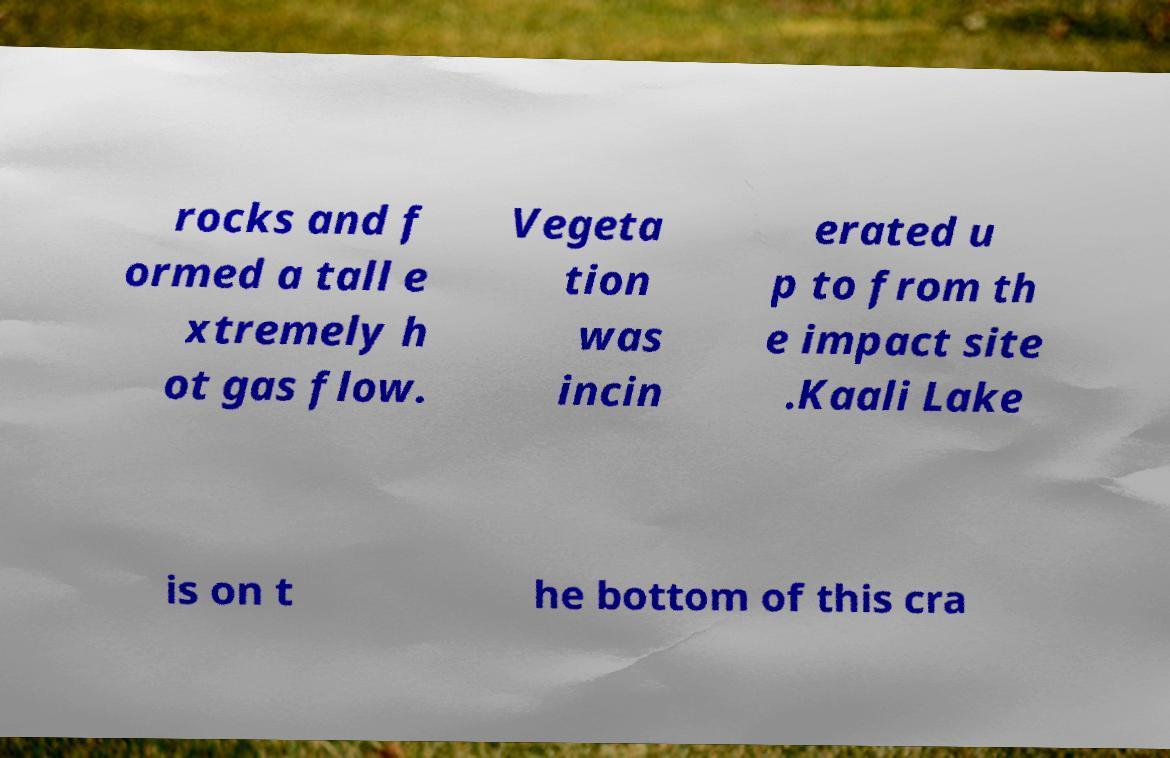Could you extract and type out the text from this image? rocks and f ormed a tall e xtremely h ot gas flow. Vegeta tion was incin erated u p to from th e impact site .Kaali Lake is on t he bottom of this cra 